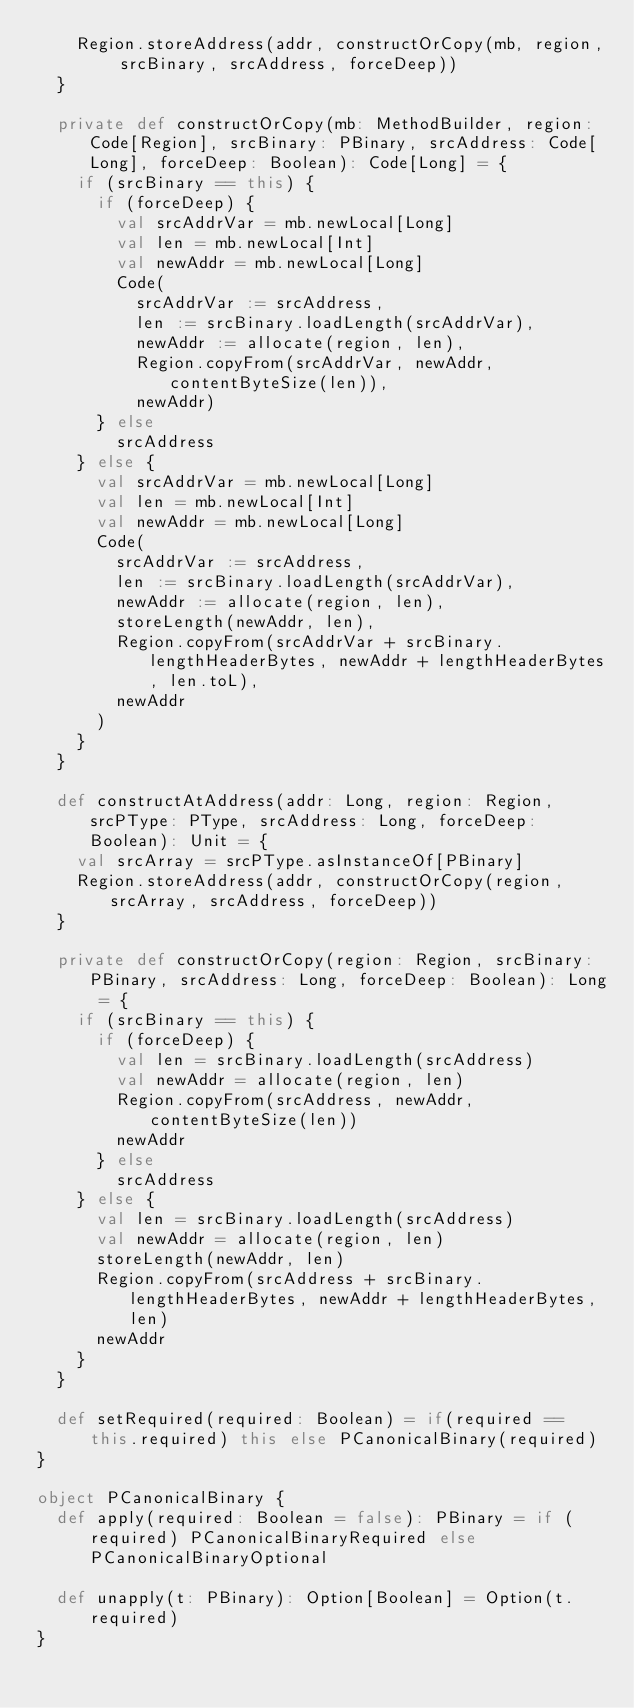<code> <loc_0><loc_0><loc_500><loc_500><_Scala_>    Region.storeAddress(addr, constructOrCopy(mb, region, srcBinary, srcAddress, forceDeep))
  }

  private def constructOrCopy(mb: MethodBuilder, region: Code[Region], srcBinary: PBinary, srcAddress: Code[Long], forceDeep: Boolean): Code[Long] = {
    if (srcBinary == this) {
      if (forceDeep) {
        val srcAddrVar = mb.newLocal[Long]
        val len = mb.newLocal[Int]
        val newAddr = mb.newLocal[Long]
        Code(
          srcAddrVar := srcAddress,
          len := srcBinary.loadLength(srcAddrVar),
          newAddr := allocate(region, len),
          Region.copyFrom(srcAddrVar, newAddr, contentByteSize(len)),
          newAddr)
      } else
        srcAddress
    } else {
      val srcAddrVar = mb.newLocal[Long]
      val len = mb.newLocal[Int]
      val newAddr = mb.newLocal[Long]
      Code(
        srcAddrVar := srcAddress,
        len := srcBinary.loadLength(srcAddrVar),
        newAddr := allocate(region, len),
        storeLength(newAddr, len),
        Region.copyFrom(srcAddrVar + srcBinary.lengthHeaderBytes, newAddr + lengthHeaderBytes, len.toL),
        newAddr
      )
    }
  }

  def constructAtAddress(addr: Long, region: Region, srcPType: PType, srcAddress: Long, forceDeep: Boolean): Unit = {
    val srcArray = srcPType.asInstanceOf[PBinary]
    Region.storeAddress(addr, constructOrCopy(region, srcArray, srcAddress, forceDeep))
  }

  private def constructOrCopy(region: Region, srcBinary: PBinary, srcAddress: Long, forceDeep: Boolean): Long = {
    if (srcBinary == this) {
      if (forceDeep) {
        val len = srcBinary.loadLength(srcAddress)
        val newAddr = allocate(region, len)
        Region.copyFrom(srcAddress, newAddr, contentByteSize(len))
        newAddr
      } else
        srcAddress
    } else {
      val len = srcBinary.loadLength(srcAddress)
      val newAddr = allocate(region, len)
      storeLength(newAddr, len)
      Region.copyFrom(srcAddress + srcBinary.lengthHeaderBytes, newAddr + lengthHeaderBytes, len)
      newAddr
    }
  }

  def setRequired(required: Boolean) = if(required == this.required) this else PCanonicalBinary(required)
}

object PCanonicalBinary {
  def apply(required: Boolean = false): PBinary = if (required) PCanonicalBinaryRequired else PCanonicalBinaryOptional

  def unapply(t: PBinary): Option[Boolean] = Option(t.required)
}
</code> 